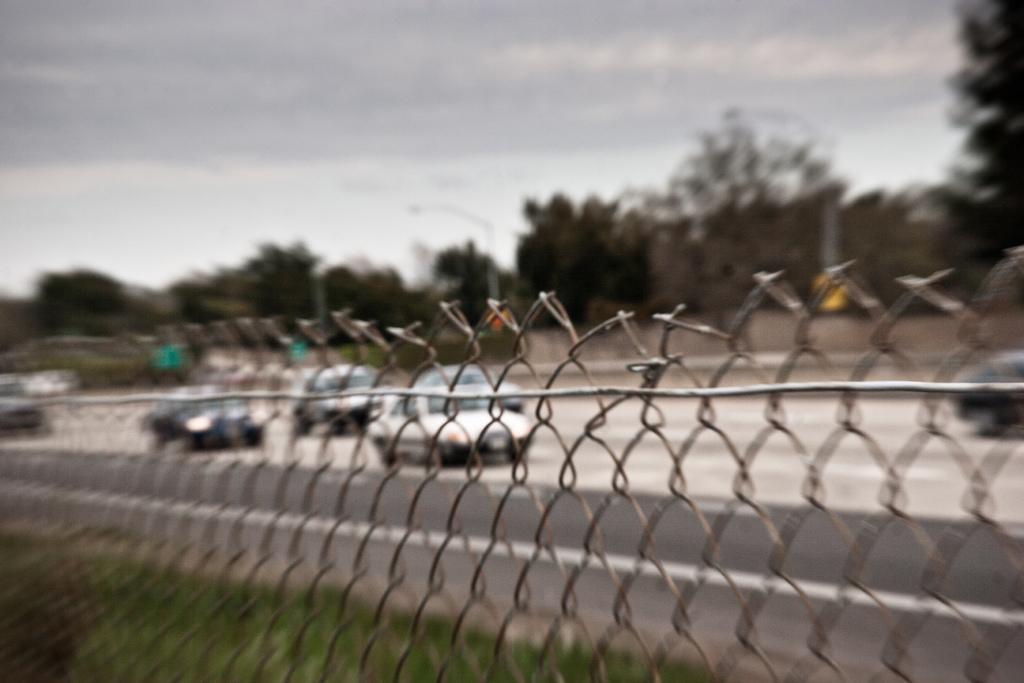Can you describe this image briefly? In this image I can see the fence and the grass. To the side I can see the vehicles on the road. In the background there are many trees, poles, clouds and the sky. 